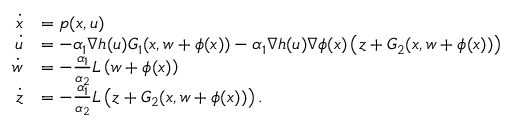Convert formula to latex. <formula><loc_0><loc_0><loc_500><loc_500>\begin{array} { r l } { \dot { x } } & { = p ( x , u ) } \\ { \dot { u } } & { = - \alpha _ { 1 } \nabla h ( u ) G _ { 1 } ( x , w + \phi ( x ) ) - \alpha _ { 1 } \nabla h ( u ) \nabla \phi ( x ) \left ( z + G _ { 2 } ( x , w + \phi ( x ) ) \right ) } \\ { \dot { w } } & { = - \frac { \alpha _ { 1 } } { \alpha _ { 2 } } L \left ( w + \phi ( x ) \right ) } \\ { \dot { z } } & { = - \frac { \alpha _ { 1 } } { \alpha _ { 2 } } L \left ( z + G _ { 2 } ( x , w + \phi ( x ) ) \right ) . } \end{array}</formula> 